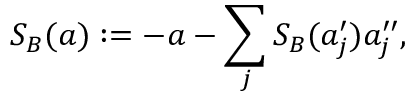Convert formula to latex. <formula><loc_0><loc_0><loc_500><loc_500>S _ { B } ( a ) \colon = - a - \sum _ { j } S _ { B } ( a _ { j } ^ { \prime } ) a _ { j } ^ { \prime \prime } ,</formula> 